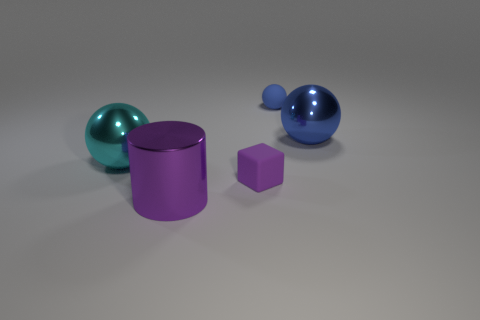Are there any other things that have the same shape as the tiny purple thing?
Your response must be concise. No. Do the large blue metal object and the big cyan metallic thing have the same shape?
Provide a succinct answer. Yes. Is there anything else of the same color as the rubber cube?
Your response must be concise. Yes. What is the shape of the thing that is made of the same material as the small ball?
Your response must be concise. Cube. There is a blue shiny thing; is it the same shape as the tiny matte thing on the left side of the tiny blue object?
Provide a succinct answer. No. The big object that is behind the shiny object that is on the left side of the big purple shiny thing is made of what material?
Offer a very short reply. Metal. Is the number of cyan things that are behind the big cyan metallic sphere the same as the number of tiny rubber things?
Offer a very short reply. No. There is a small object behind the large blue metallic ball; does it have the same color as the big metal ball to the right of the small purple matte object?
Your answer should be compact. Yes. How many objects are both in front of the small blue rubber object and behind the large purple object?
Your answer should be compact. 3. How many other objects are there of the same shape as the blue matte object?
Make the answer very short. 2. 